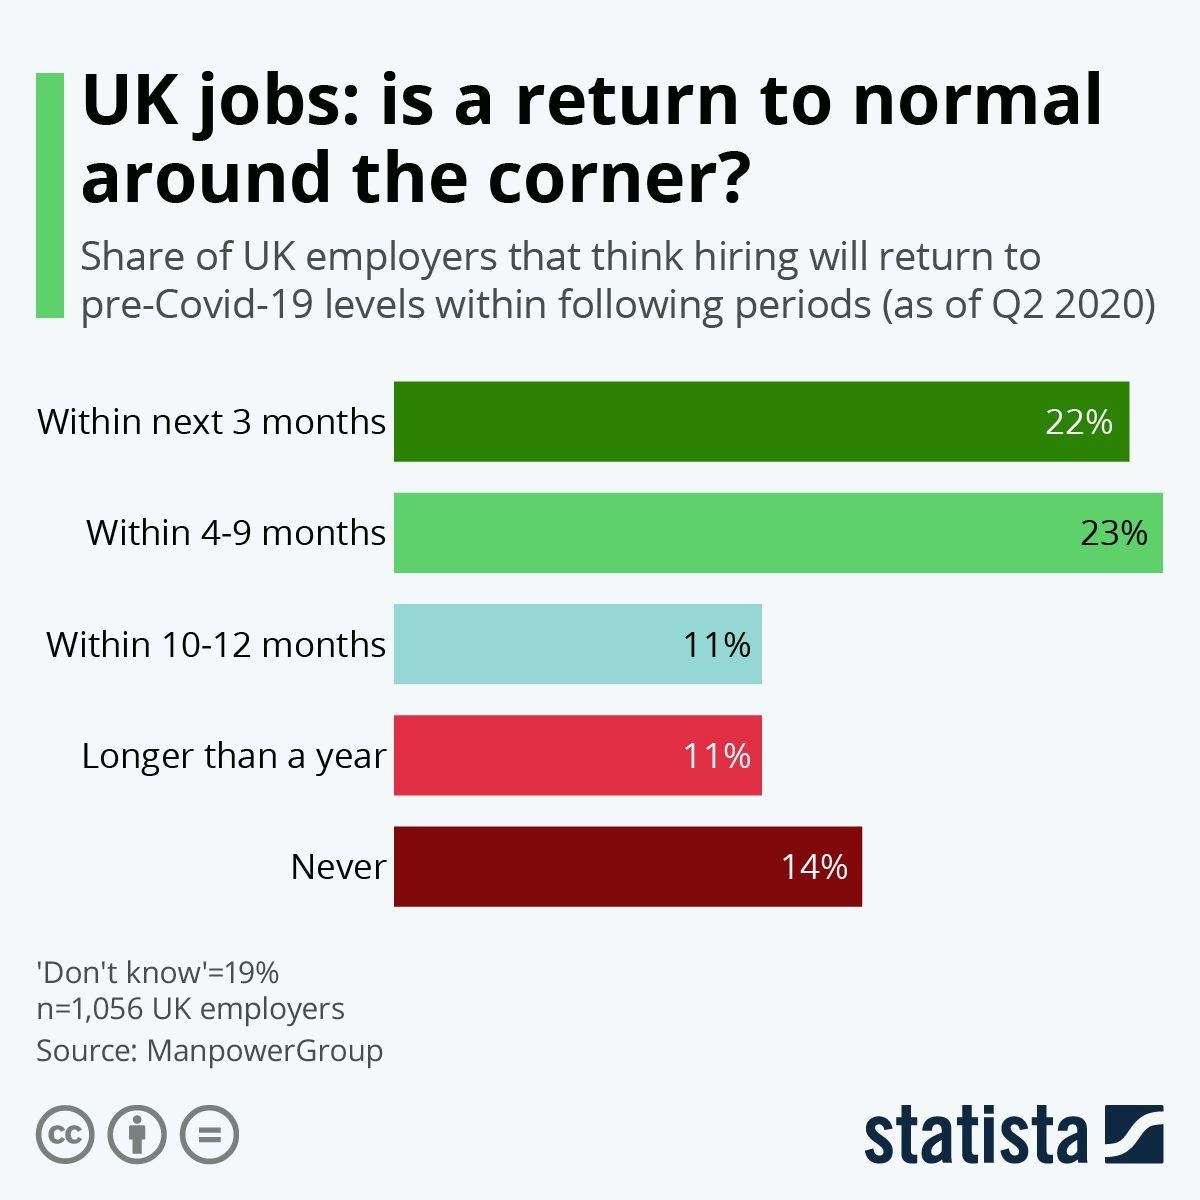Identify some key points in this picture. According to a recent survey, 23% of UK employers believe that hiring will return to pre-Covid-19 levels within 4-9 months as of Q2 2020. According to a survey conducted in the second quarter of 2020, 14% of UK employers believe that hiring will never return to its pre-Covid-19 levels. According to a survey conducted by a UK-based agency, a mere 11% of employers believe that hiring will return to pre-Covid-19 levels within 10-12 months as of Q2 2020. According to a recent survey, 22% of UK employers believe that hiring will return to pre-Covid-19 levels within the next 3 months as of Q2 2020. 